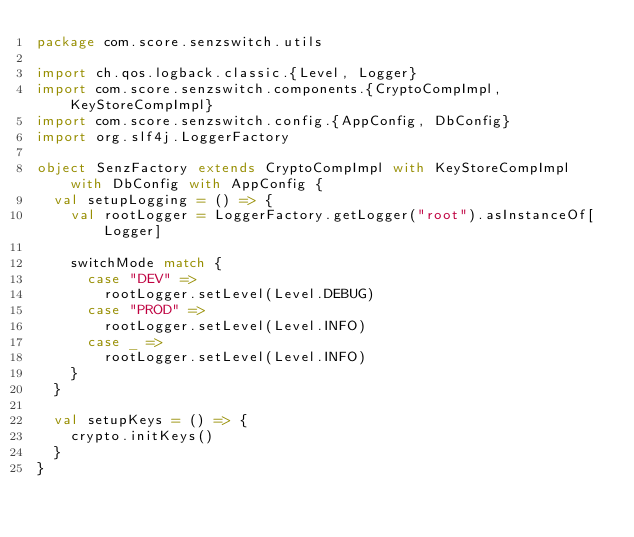<code> <loc_0><loc_0><loc_500><loc_500><_Scala_>package com.score.senzswitch.utils

import ch.qos.logback.classic.{Level, Logger}
import com.score.senzswitch.components.{CryptoCompImpl, KeyStoreCompImpl}
import com.score.senzswitch.config.{AppConfig, DbConfig}
import org.slf4j.LoggerFactory

object SenzFactory extends CryptoCompImpl with KeyStoreCompImpl with DbConfig with AppConfig {
  val setupLogging = () => {
    val rootLogger = LoggerFactory.getLogger("root").asInstanceOf[Logger]

    switchMode match {
      case "DEV" =>
        rootLogger.setLevel(Level.DEBUG)
      case "PROD" =>
        rootLogger.setLevel(Level.INFO)
      case _ =>
        rootLogger.setLevel(Level.INFO)
    }
  }

  val setupKeys = () => {
    crypto.initKeys()
  }
}
</code> 